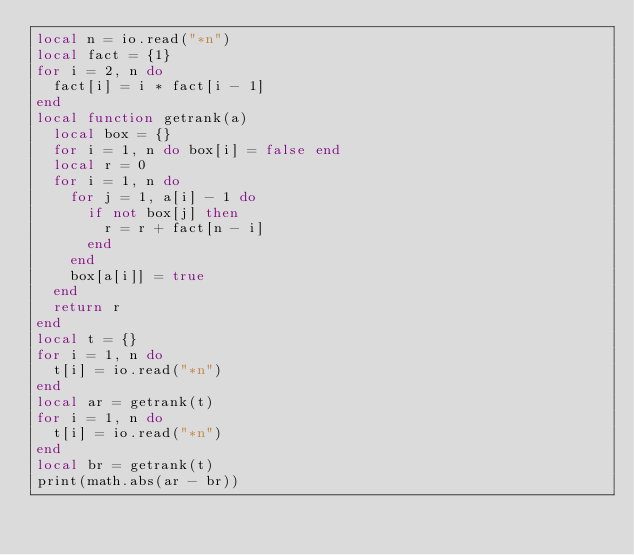<code> <loc_0><loc_0><loc_500><loc_500><_Lua_>local n = io.read("*n")
local fact = {1}
for i = 2, n do
  fact[i] = i * fact[i - 1]
end
local function getrank(a)
  local box = {}
  for i = 1, n do box[i] = false end
  local r = 0
  for i = 1, n do
    for j = 1, a[i] - 1 do
      if not box[j] then
        r = r + fact[n - i]
      end
    end
    box[a[i]] = true
  end
  return r
end
local t = {}
for i = 1, n do
  t[i] = io.read("*n")
end
local ar = getrank(t)
for i = 1, n do
  t[i] = io.read("*n")
end
local br = getrank(t)
print(math.abs(ar - br))
</code> 